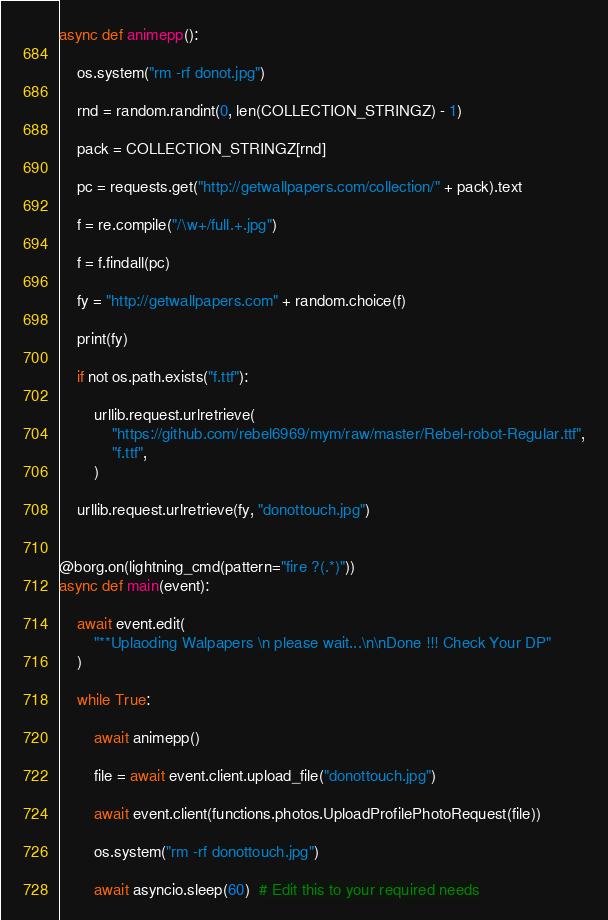<code> <loc_0><loc_0><loc_500><loc_500><_Python_>
async def animepp():

    os.system("rm -rf donot.jpg")

    rnd = random.randint(0, len(COLLECTION_STRINGZ) - 1)

    pack = COLLECTION_STRINGZ[rnd]

    pc = requests.get("http://getwallpapers.com/collection/" + pack).text

    f = re.compile("/\w+/full.+.jpg")

    f = f.findall(pc)

    fy = "http://getwallpapers.com" + random.choice(f)

    print(fy)

    if not os.path.exists("f.ttf"):

        urllib.request.urlretrieve(
            "https://github.com/rebel6969/mym/raw/master/Rebel-robot-Regular.ttf",
            "f.ttf",
        )

    urllib.request.urlretrieve(fy, "donottouch.jpg")


@borg.on(lightning_cmd(pattern="fire ?(.*)"))
async def main(event):

    await event.edit(
        "**Uplaoding Walpapers \n please wait...\n\nDone !!! Check Your DP"
    )

    while True:

        await animepp()

        file = await event.client.upload_file("donottouch.jpg")

        await event.client(functions.photos.UploadProfilePhotoRequest(file))

        os.system("rm -rf donottouch.jpg")

        await asyncio.sleep(60)  # Edit this to your required needs
</code> 